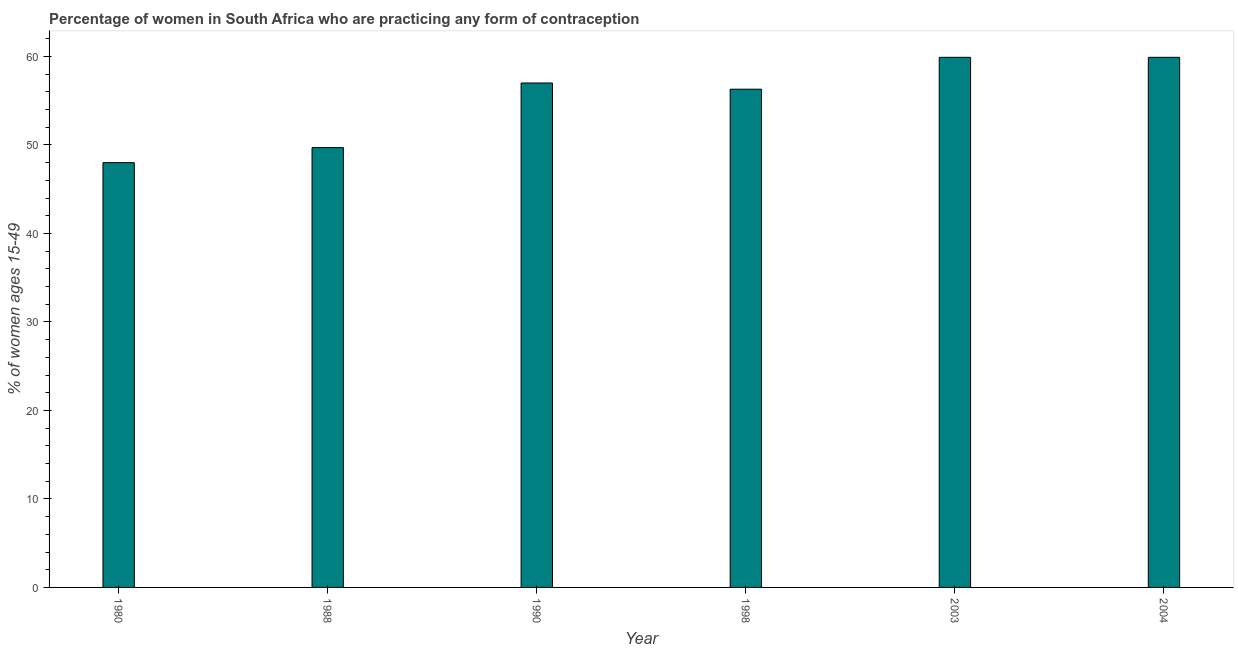Does the graph contain any zero values?
Offer a terse response. No. Does the graph contain grids?
Your answer should be compact. No. What is the title of the graph?
Provide a succinct answer. Percentage of women in South Africa who are practicing any form of contraception. What is the label or title of the X-axis?
Your response must be concise. Year. What is the label or title of the Y-axis?
Your response must be concise. % of women ages 15-49. What is the contraceptive prevalence in 1990?
Keep it short and to the point. 57. Across all years, what is the maximum contraceptive prevalence?
Your answer should be very brief. 59.9. In which year was the contraceptive prevalence minimum?
Make the answer very short. 1980. What is the sum of the contraceptive prevalence?
Make the answer very short. 330.8. What is the difference between the contraceptive prevalence in 1980 and 2003?
Ensure brevity in your answer.  -11.9. What is the average contraceptive prevalence per year?
Your answer should be compact. 55.13. What is the median contraceptive prevalence?
Provide a succinct answer. 56.65. What is the ratio of the contraceptive prevalence in 1998 to that in 2003?
Your answer should be compact. 0.94. Is the contraceptive prevalence in 1980 less than that in 2003?
Your response must be concise. Yes. What is the difference between the highest and the second highest contraceptive prevalence?
Offer a terse response. 0. Is the sum of the contraceptive prevalence in 1980 and 1990 greater than the maximum contraceptive prevalence across all years?
Give a very brief answer. Yes. What is the difference between the highest and the lowest contraceptive prevalence?
Your answer should be very brief. 11.9. In how many years, is the contraceptive prevalence greater than the average contraceptive prevalence taken over all years?
Your response must be concise. 4. How many years are there in the graph?
Keep it short and to the point. 6. Are the values on the major ticks of Y-axis written in scientific E-notation?
Your answer should be compact. No. What is the % of women ages 15-49 of 1988?
Your answer should be very brief. 49.7. What is the % of women ages 15-49 in 1990?
Make the answer very short. 57. What is the % of women ages 15-49 in 1998?
Ensure brevity in your answer.  56.3. What is the % of women ages 15-49 in 2003?
Provide a succinct answer. 59.9. What is the % of women ages 15-49 in 2004?
Your answer should be very brief. 59.9. What is the difference between the % of women ages 15-49 in 1980 and 1988?
Your answer should be compact. -1.7. What is the difference between the % of women ages 15-49 in 1980 and 1998?
Make the answer very short. -8.3. What is the difference between the % of women ages 15-49 in 1980 and 2004?
Give a very brief answer. -11.9. What is the difference between the % of women ages 15-49 in 1988 and 1990?
Give a very brief answer. -7.3. What is the difference between the % of women ages 15-49 in 1988 and 2003?
Make the answer very short. -10.2. What is the difference between the % of women ages 15-49 in 1988 and 2004?
Provide a short and direct response. -10.2. What is the difference between the % of women ages 15-49 in 1990 and 1998?
Provide a short and direct response. 0.7. What is the difference between the % of women ages 15-49 in 1990 and 2003?
Offer a very short reply. -2.9. What is the difference between the % of women ages 15-49 in 1998 and 2004?
Offer a terse response. -3.6. What is the ratio of the % of women ages 15-49 in 1980 to that in 1988?
Your answer should be compact. 0.97. What is the ratio of the % of women ages 15-49 in 1980 to that in 1990?
Offer a terse response. 0.84. What is the ratio of the % of women ages 15-49 in 1980 to that in 1998?
Ensure brevity in your answer.  0.85. What is the ratio of the % of women ages 15-49 in 1980 to that in 2003?
Make the answer very short. 0.8. What is the ratio of the % of women ages 15-49 in 1980 to that in 2004?
Provide a short and direct response. 0.8. What is the ratio of the % of women ages 15-49 in 1988 to that in 1990?
Give a very brief answer. 0.87. What is the ratio of the % of women ages 15-49 in 1988 to that in 1998?
Your response must be concise. 0.88. What is the ratio of the % of women ages 15-49 in 1988 to that in 2003?
Keep it short and to the point. 0.83. What is the ratio of the % of women ages 15-49 in 1988 to that in 2004?
Your answer should be very brief. 0.83. What is the ratio of the % of women ages 15-49 in 1990 to that in 2003?
Offer a terse response. 0.95. What is the ratio of the % of women ages 15-49 in 1990 to that in 2004?
Provide a short and direct response. 0.95. What is the ratio of the % of women ages 15-49 in 1998 to that in 2004?
Your answer should be compact. 0.94. What is the ratio of the % of women ages 15-49 in 2003 to that in 2004?
Give a very brief answer. 1. 